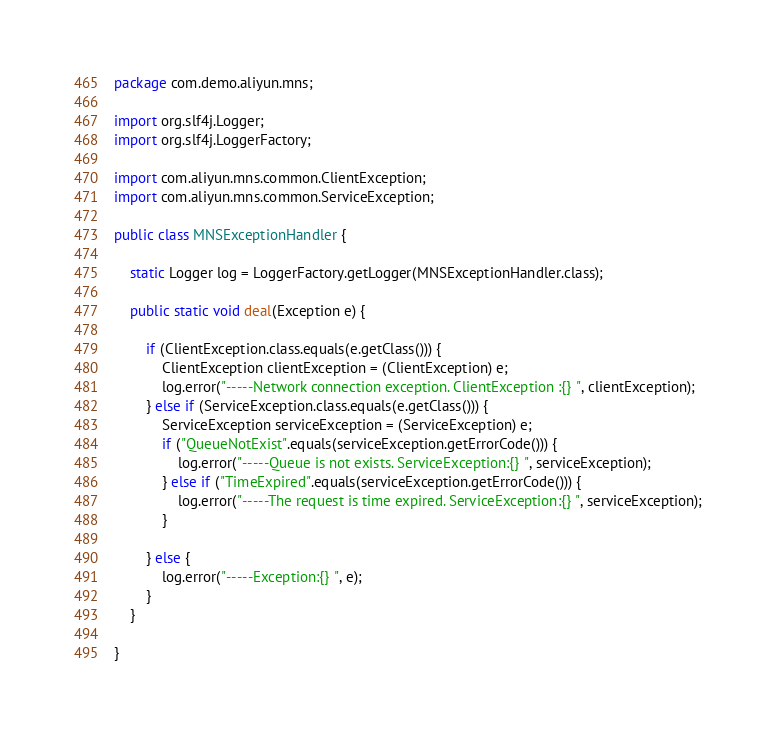<code> <loc_0><loc_0><loc_500><loc_500><_Java_>package com.demo.aliyun.mns;

import org.slf4j.Logger;
import org.slf4j.LoggerFactory;

import com.aliyun.mns.common.ClientException;
import com.aliyun.mns.common.ServiceException;

public class MNSExceptionHandler {

	static Logger log = LoggerFactory.getLogger(MNSExceptionHandler.class);

	public static void deal(Exception e) {

		if (ClientException.class.equals(e.getClass())) {
			ClientException clientException = (ClientException) e;
			log.error("-----Network connection exception. ClientException :{} ", clientException);
		} else if (ServiceException.class.equals(e.getClass())) {
			ServiceException serviceException = (ServiceException) e;
			if ("QueueNotExist".equals(serviceException.getErrorCode())) {
				log.error("-----Queue is not exists. ServiceException:{} ", serviceException);
			} else if ("TimeExpired".equals(serviceException.getErrorCode())) {
				log.error("-----The request is time expired. ServiceException:{} ", serviceException);
			}

		} else {
			log.error("-----Exception:{} ", e);
		}
	}

}
</code> 